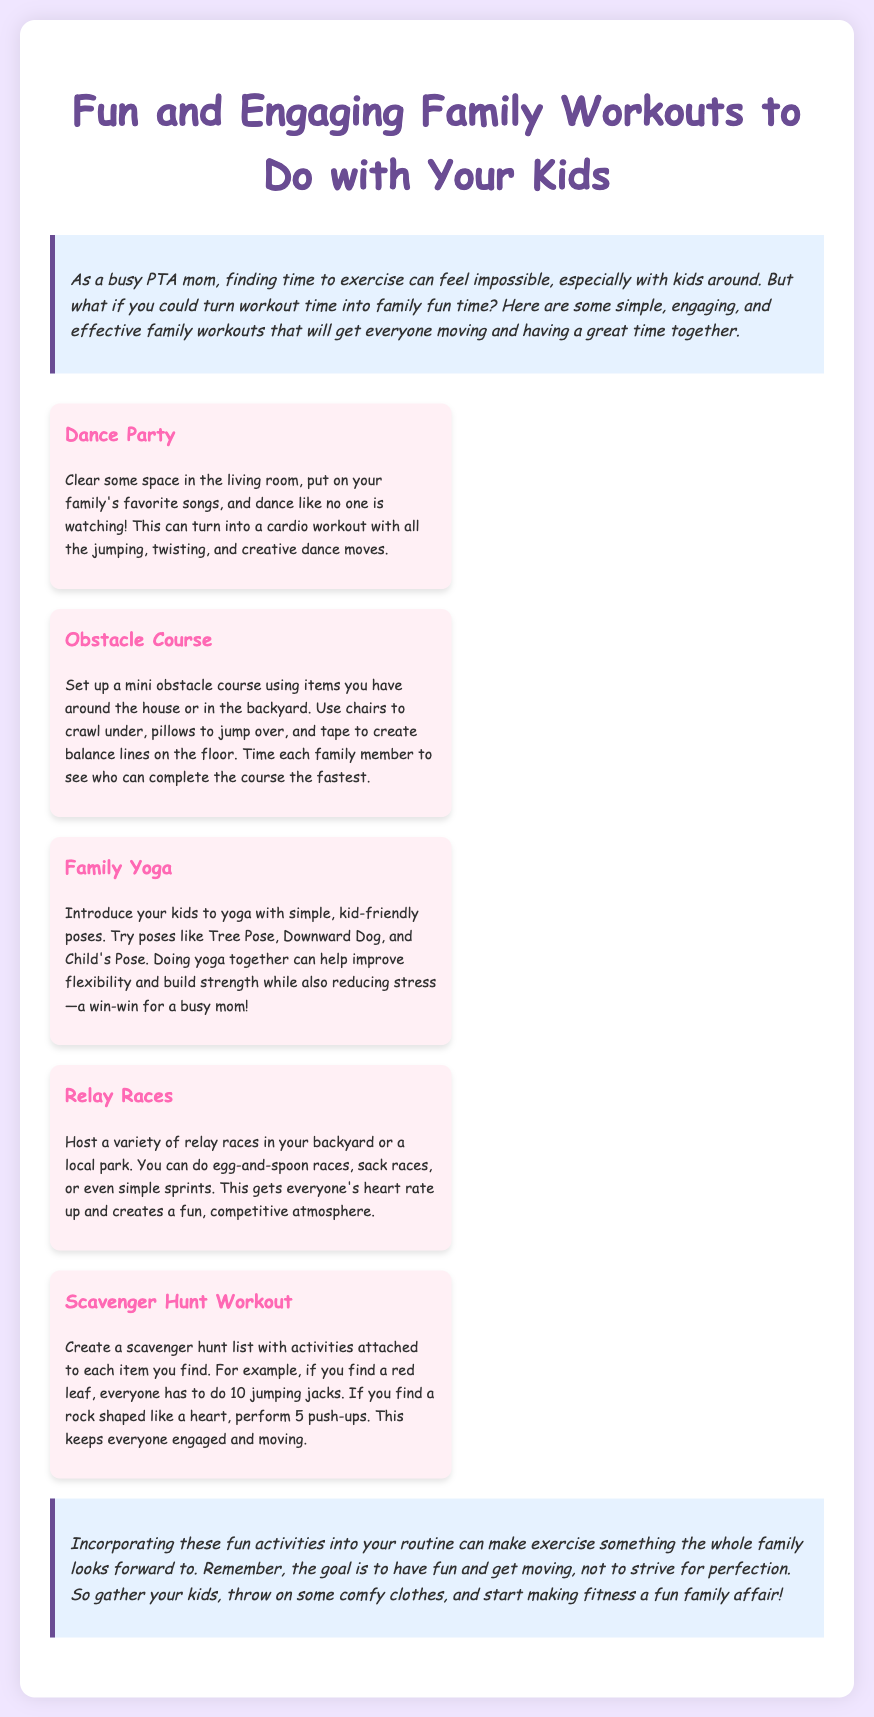What is the title of the document? The title is found in the header of the document, which states "Fun and Engaging Family Workouts to Do with Your Kids."
Answer: Fun and Engaging Family Workouts to Do with Your Kids How many activities are listed in the workout plan? The workout plan section contains five activities detailed in separate sections.
Answer: 5 What is the first activity mentioned in the document? The first activity stated in the workout plan is "Dance Party."
Answer: Dance Party What is one benefit of doing family yoga together? The document mentions that family yoga can help improve flexibility and build strength.
Answer: Improve flexibility Which activity involves creating a mini obstacle course? The specific activity that involves an obstacle course is titled "Obstacle Course."
Answer: Obstacle Course What type of races can families host in their backyard or park? The document includes relay races, egg-and-spoon races, sack races, and sprints as examples.
Answer: Relay races What color is the background of the document? The overall background color of the document is a light shade of purple, specifically #f0e6ff.
Answer: Light purple What is the closing statement's main idea? The closing statement emphasizes the importance of having fun and making fitness a family affair.
Answer: Have fun 